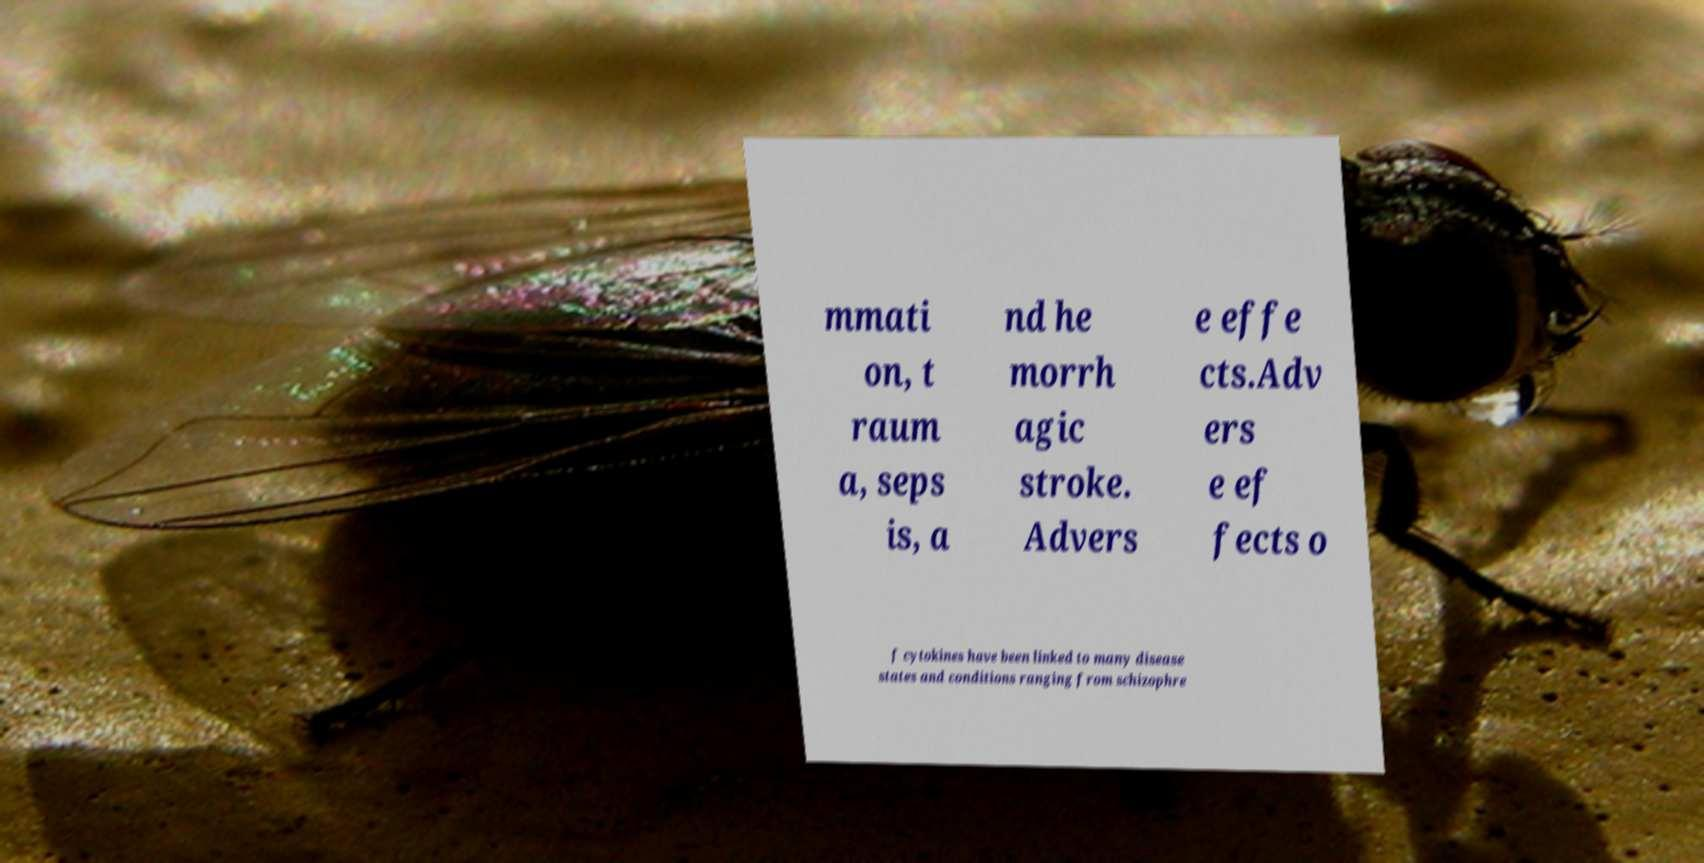What messages or text are displayed in this image? I need them in a readable, typed format. mmati on, t raum a, seps is, a nd he morrh agic stroke. Advers e effe cts.Adv ers e ef fects o f cytokines have been linked to many disease states and conditions ranging from schizophre 